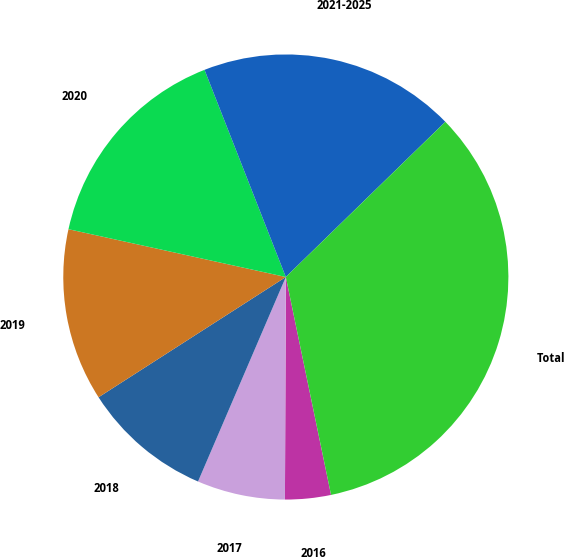Convert chart to OTSL. <chart><loc_0><loc_0><loc_500><loc_500><pie_chart><fcel>2016<fcel>2017<fcel>2018<fcel>2019<fcel>2020<fcel>2021-2025<fcel>Total<nl><fcel>3.32%<fcel>6.39%<fcel>9.46%<fcel>12.53%<fcel>15.6%<fcel>18.67%<fcel>34.02%<nl></chart> 